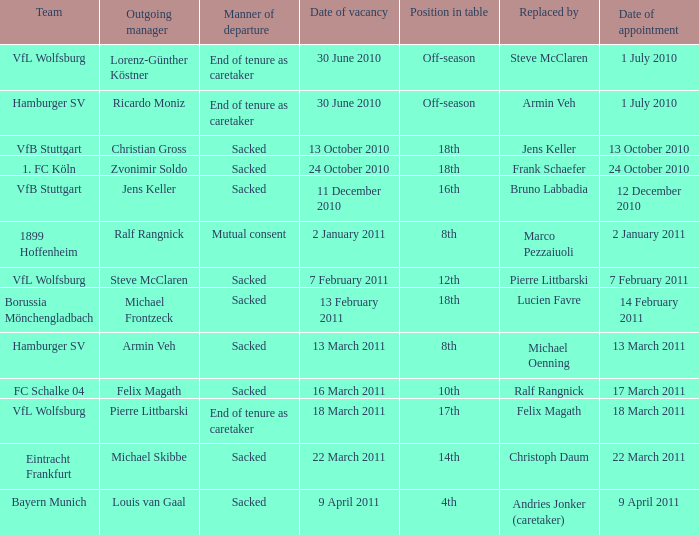What is the method of departure when steve mcclaren takes over as the substitute? End of tenure as caretaker. 